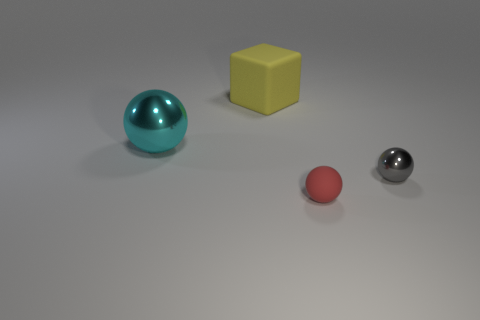Are there any other things that are the same shape as the yellow object?
Offer a terse response. No. Is there a big cyan metallic thing to the left of the sphere behind the metallic object that is to the right of the matte ball?
Your answer should be very brief. No. What shape is the cyan metal object that is the same size as the yellow matte cube?
Your answer should be very brief. Sphere. Are there any cyan shiny objects behind the small gray metallic sphere?
Offer a terse response. Yes. Is the yellow cube the same size as the matte sphere?
Offer a terse response. No. What shape is the shiny thing that is to the left of the small red matte ball?
Give a very brief answer. Sphere. Is there a yellow block that has the same size as the rubber ball?
Offer a terse response. No. What material is the other ball that is the same size as the gray sphere?
Your answer should be very brief. Rubber. There is a rubber object that is in front of the large cyan thing; what size is it?
Your answer should be very brief. Small. The gray object is what size?
Provide a short and direct response. Small. 